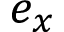<formula> <loc_0><loc_0><loc_500><loc_500>e _ { x }</formula> 